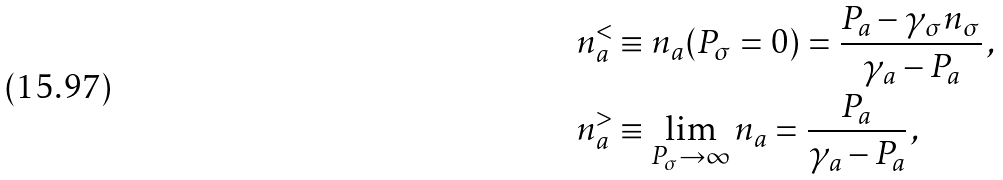Convert formula to latex. <formula><loc_0><loc_0><loc_500><loc_500>n _ { a } ^ { < } & \equiv n _ { a } ( P _ { \sigma } = 0 ) = \frac { P _ { a } - \gamma _ { \sigma } n _ { \sigma } } { \gamma _ { a } - P _ { a } } \, , \\ n _ { a } ^ { > } & \equiv \lim _ { P _ { \sigma } \rightarrow \infty } n _ { a } = \frac { P _ { a } } { \gamma _ { a } - P _ { a } } \, ,</formula> 